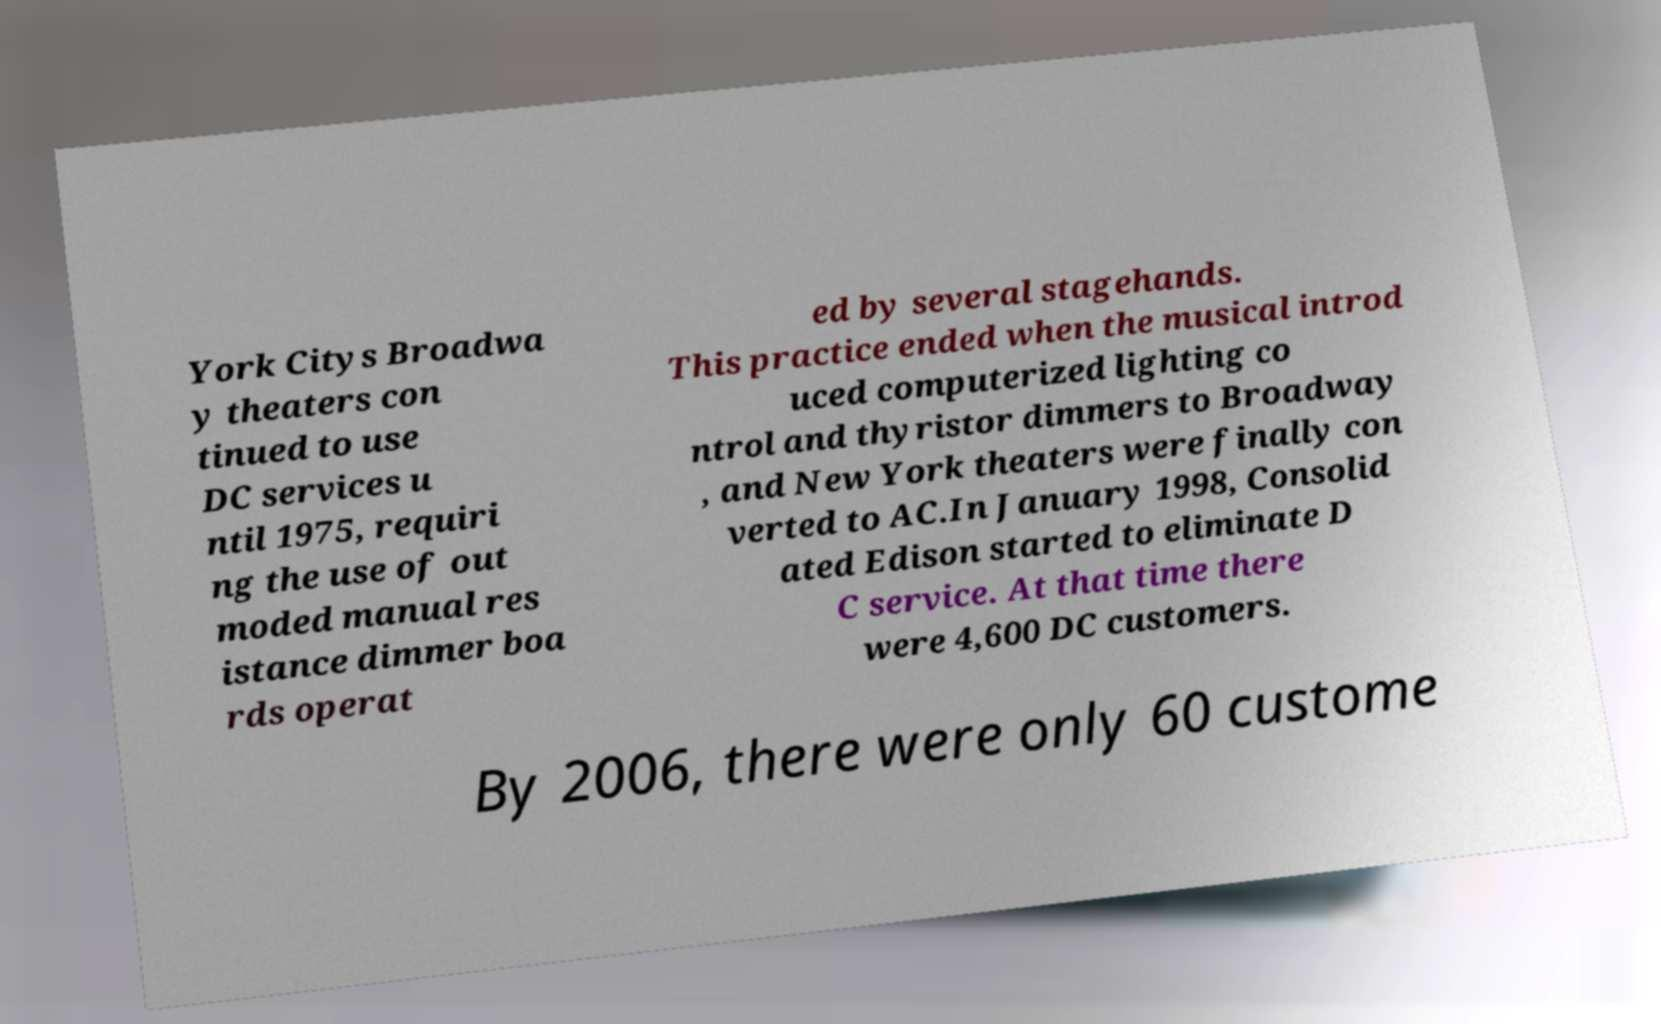I need the written content from this picture converted into text. Can you do that? York Citys Broadwa y theaters con tinued to use DC services u ntil 1975, requiri ng the use of out moded manual res istance dimmer boa rds operat ed by several stagehands. This practice ended when the musical introd uced computerized lighting co ntrol and thyristor dimmers to Broadway , and New York theaters were finally con verted to AC.In January 1998, Consolid ated Edison started to eliminate D C service. At that time there were 4,600 DC customers. By 2006, there were only 60 custome 